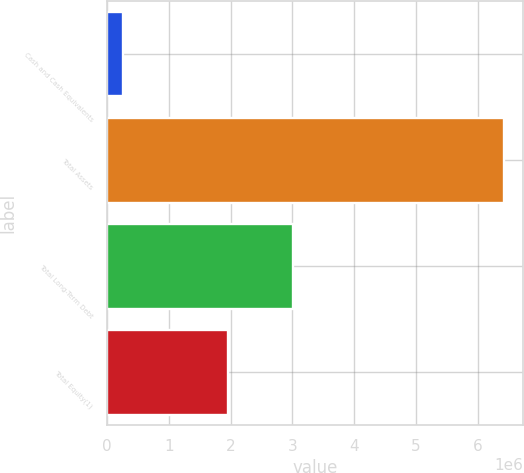Convert chart to OTSL. <chart><loc_0><loc_0><loc_500><loc_500><bar_chart><fcel>Cash and Cash Equivalents<fcel>Total Assets<fcel>Total Long-Term Debt<fcel>Total Equity(1)<nl><fcel>258693<fcel>6.41639e+06<fcel>3.00821e+06<fcel>1.95286e+06<nl></chart> 